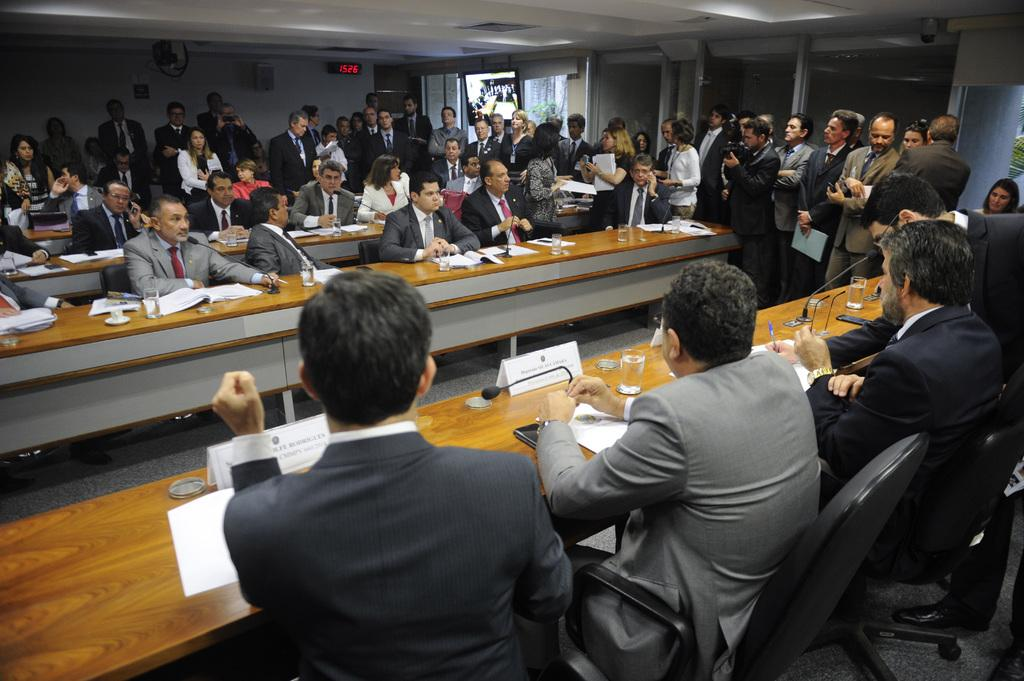How many people are in the image? There is a group of people in the image, but the exact number is not specified. What are the people in the image doing? A meeting is taking place, and some people are sitting while others are standing. What are the seated people using to address the group? There are microphones on the table in front of the seated people. What are the people sitting on? The people are sitting on chairs. What type of insect can be seen crawling on the table during the meeting? There is no insect present on the table during the meeting; the image only shows people and microphones. 